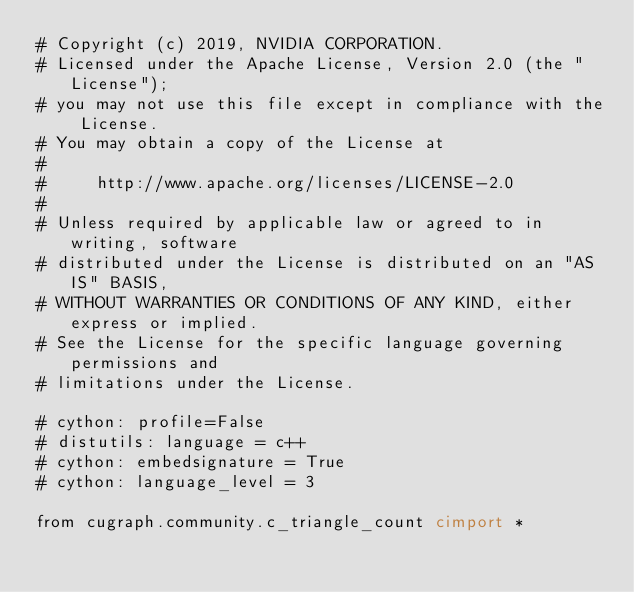<code> <loc_0><loc_0><loc_500><loc_500><_Cython_># Copyright (c) 2019, NVIDIA CORPORATION.
# Licensed under the Apache License, Version 2.0 (the "License");
# you may not use this file except in compliance with the License.
# You may obtain a copy of the License at
#
#     http://www.apache.org/licenses/LICENSE-2.0
#
# Unless required by applicable law or agreed to in writing, software
# distributed under the License is distributed on an "AS IS" BASIS,
# WITHOUT WARRANTIES OR CONDITIONS OF ANY KIND, either express or implied.
# See the License for the specific language governing permissions and
# limitations under the License.

# cython: profile=False
# distutils: language = c++
# cython: embedsignature = True
# cython: language_level = 3

from cugraph.community.c_triangle_count cimport *</code> 